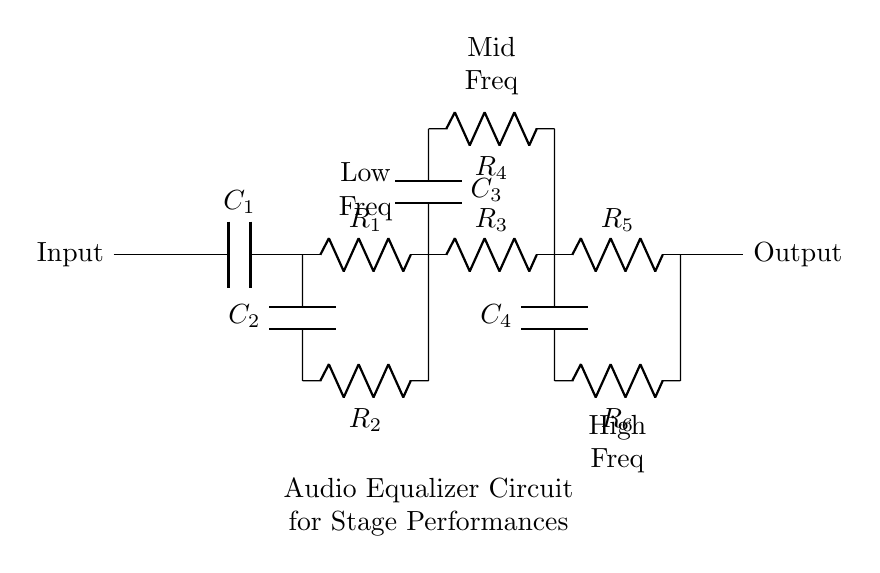What is the total number of resistors in the circuit? The circuit consists of six resistors labeled R1 through R6, as indicated by the components present in the diagram.
Answer: six What type of components are used for frequency filtering? The circuit contains capacitors (C1 to C4) and resistors (R1 to R6) which are essential for creating filters that define the low, mid, and high frequency ranges.
Answer: capacitors and resistors Which section corresponds to high frequencies? The section labeled "High Freq" contains the components connected to R5 and C4, specifically designed for filtering high-frequency signals.
Answer: High Freq What is the role of capacitor C2? Capacitor C2 is positioned in the low-frequency section, which indicates it is part of a low-pass filter, allowing low frequencies to pass while blocking higher frequencies.
Answer: Low-pass filter How many frequency sections are present in the circuit? The circuit is organized into three distinct frequency sections: low, mid, and high frequencies, each serving to filter a specific range of frequencies.
Answer: three What is the purpose of resistor R4? Resistor R4, located in the mid-frequency section, works in conjunction with capacitor C3 to help determine the cutoff frequency for mid-range audio signals, affecting the response of that frequency band.
Answer: Mid-range cutoff What label identifies the output of this circuit? The output of the circuit is labeled "Output" located to the right of all the components, which denotes where the processed audio signal will be sent out from the equalizer.
Answer: Output 